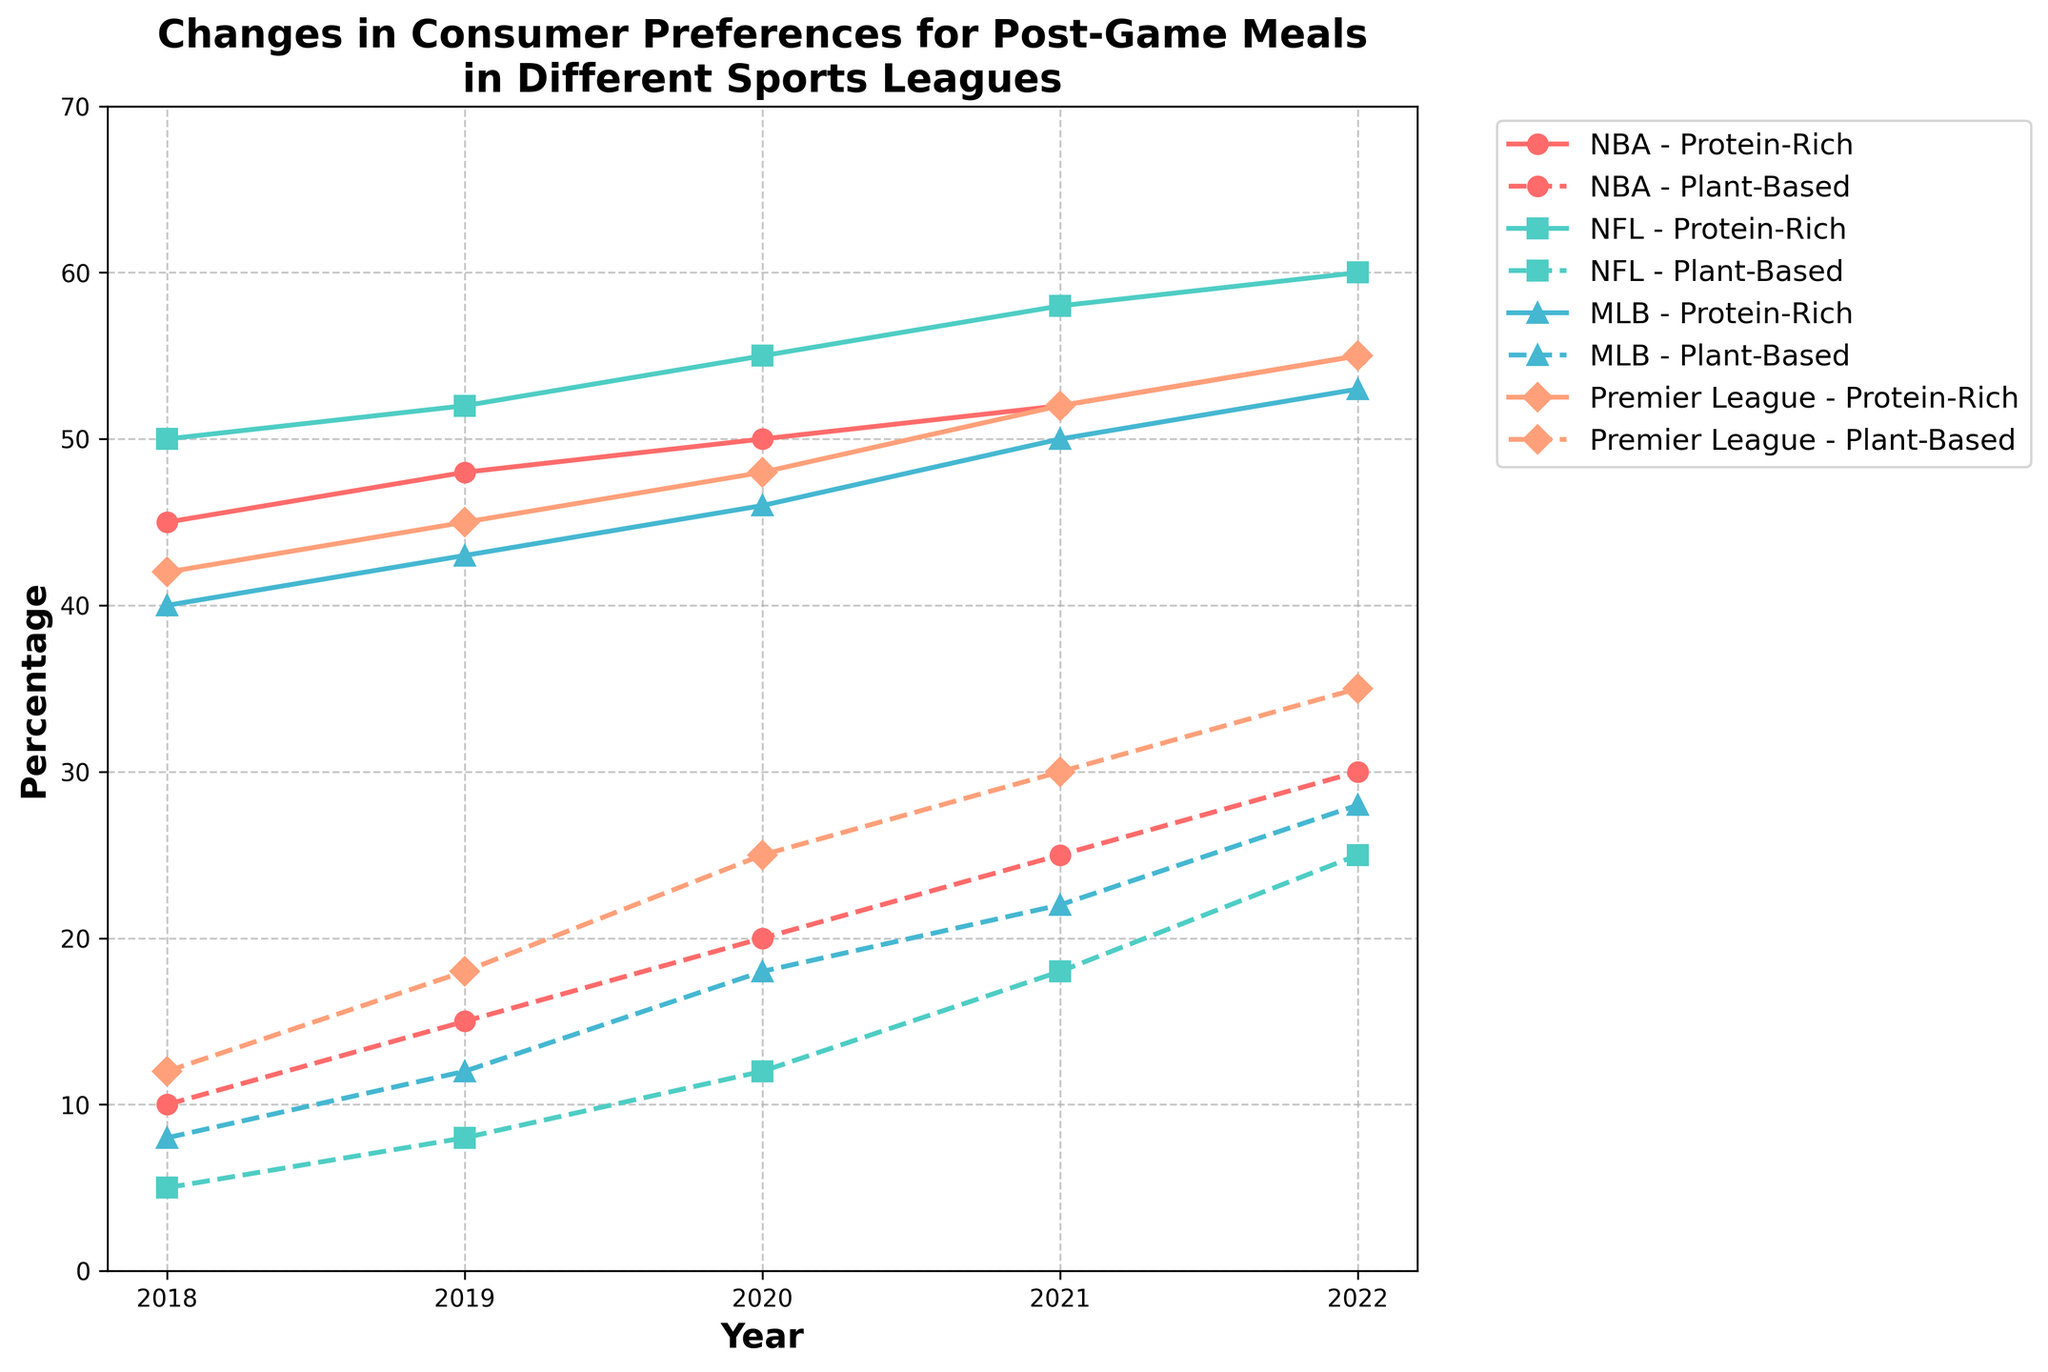Which sport saw the highest increase in preference for Protein-Rich Meals from 2018 to 2022? First, check the percentage of Protein-Rich Meals for each sport in both 2018 and 2022. For NBA, it increased from 45% to 55%, an increase of 10%. For NFL, it increased from 50% to 60%, an increase of 10%. For MLB, it increased from 40% to 53%, an increase of 13%. For Premier League, it increased from 42% to 55%, an increase of 13%. Both MLB and Premier League saw the highest increase, which is 13%.
Answer: MLB and Premier League Which sport had the lowest preference for Plant-Based Options in 2018? Look at the values of Plant-Based Options in 2018 for each sport. NBA had 10%, NFL had 5%, MLB had 8%, and Premier League had 12%. Therefore, NFL had the lowest preference for Plant-Based Options in 2018.
Answer: NFL In which year did the Premier League first surpass 50% preference for Protein-Rich Meals? Check the Premier League's Protein-Rich Meals percentages year by year. In 2021, the percentage was 52%, which is the first year it surpassed 50%.
Answer: 2021 Which meal category showed a consistent decrease in preference across all sports from 2018 to 2022? Examine the trend lines for each meal category across all sports. Recovery Shakes consistently decreased in preference for NBA (10% to 3%), NFL (5% to 2%), MLB (7% to 3%), and Premier League (8% to 2%).
Answer: Recovery Shakes Which sport had the highest preference for Protein-Rich Meals in 2020? Look at the percentages of Protein-Rich Meals for each sport in 2020. NBA had 50%, NFL had 55%, MLB had 46%, and Premier League had 48%. NFL had the highest preference that year.
Answer: NFL Compare the preference percentages for Comfort Foods in MLB and Premier League for 2020. Which sport had a higher percentage? In 2020, MLB had a preference percentage for Comfort Foods of 32%, whereas Premier League had 24%. MLB had the higher percentage.
Answer: MLB What is the total increase in preference for Plant-Based Options in the NBA from 2018 to 2022? Subtract the percentage of Plant-Based Options in 2018 from 2022 for NBA: 30% (2022) - 10% (2018) = 20%.
Answer: 20% How did the preference for Recovery Shakes change from 2018 to 2022 in the NFL? Look at the percentages for Recovery Shakes in the NFL: It decreased from 5% in 2018 to 2% in 2022. The change is 5% - 2% = 3%.
Answer: Decreased by 3% Which sport had the smallest change in preference for Plant-Based Options from 2018 to 2022? Calculate the change for each sport. NBA: 30% - 10% = 20%, NFL: 25% - 5% = 20%, MLB: 28% - 8% = 20%, Premier League: 35% - 12% = 23%. All changes are equal except for Premier League. The smallest change is 20%.
Answer: NBA, NFL, and MLB In 2022, which sport had the highest combined preference percentage for Comfort Foods and Recovery Shakes? Add the percentages for Comfort Foods and Recovery Shakes for each sport in 2022. NBA: 12% + 3% = 15%, NFL: 13% + 2% = 15%, MLB: 16% + 3% = 19%, Premier League: 8% + 2% = 10%. MLB has the highest combined preference percentage.
Answer: MLB 